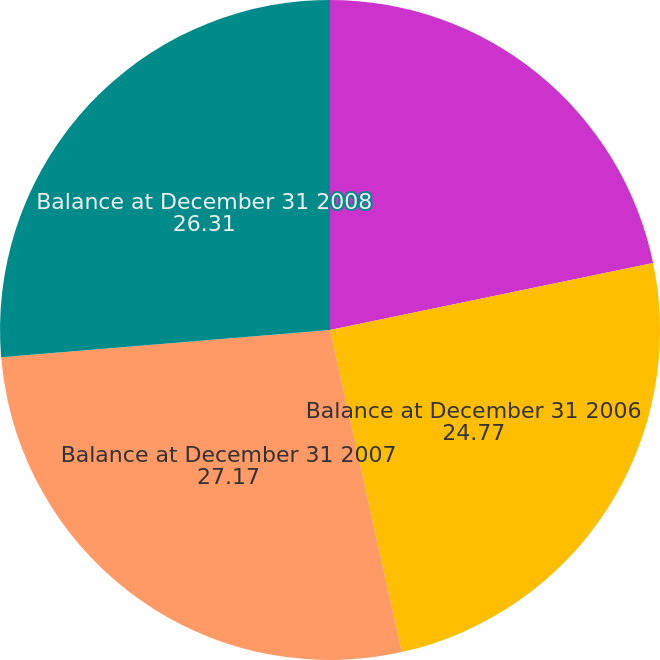Convert chart. <chart><loc_0><loc_0><loc_500><loc_500><pie_chart><fcel>Balance at January 1 2006<fcel>Balance at December 31 2006<fcel>Balance at December 31 2007<fcel>Balance at December 31 2008<nl><fcel>21.74%<fcel>24.77%<fcel>27.17%<fcel>26.31%<nl></chart> 